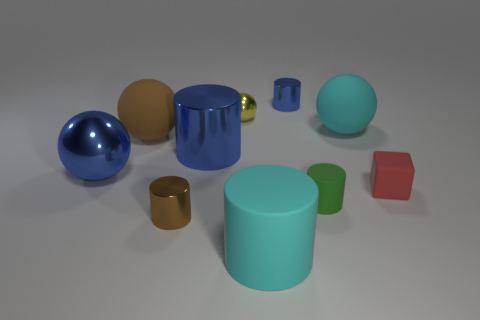Subtract all large spheres. How many spheres are left? 1 Subtract all brown cylinders. How many cylinders are left? 4 Subtract all purple cylinders. Subtract all purple cubes. How many cylinders are left? 5 Subtract all spheres. How many objects are left? 6 Subtract all cyan matte objects. Subtract all green objects. How many objects are left? 7 Add 5 tiny red objects. How many tiny red objects are left? 6 Add 8 large metallic balls. How many large metallic balls exist? 9 Subtract 0 yellow cylinders. How many objects are left? 10 